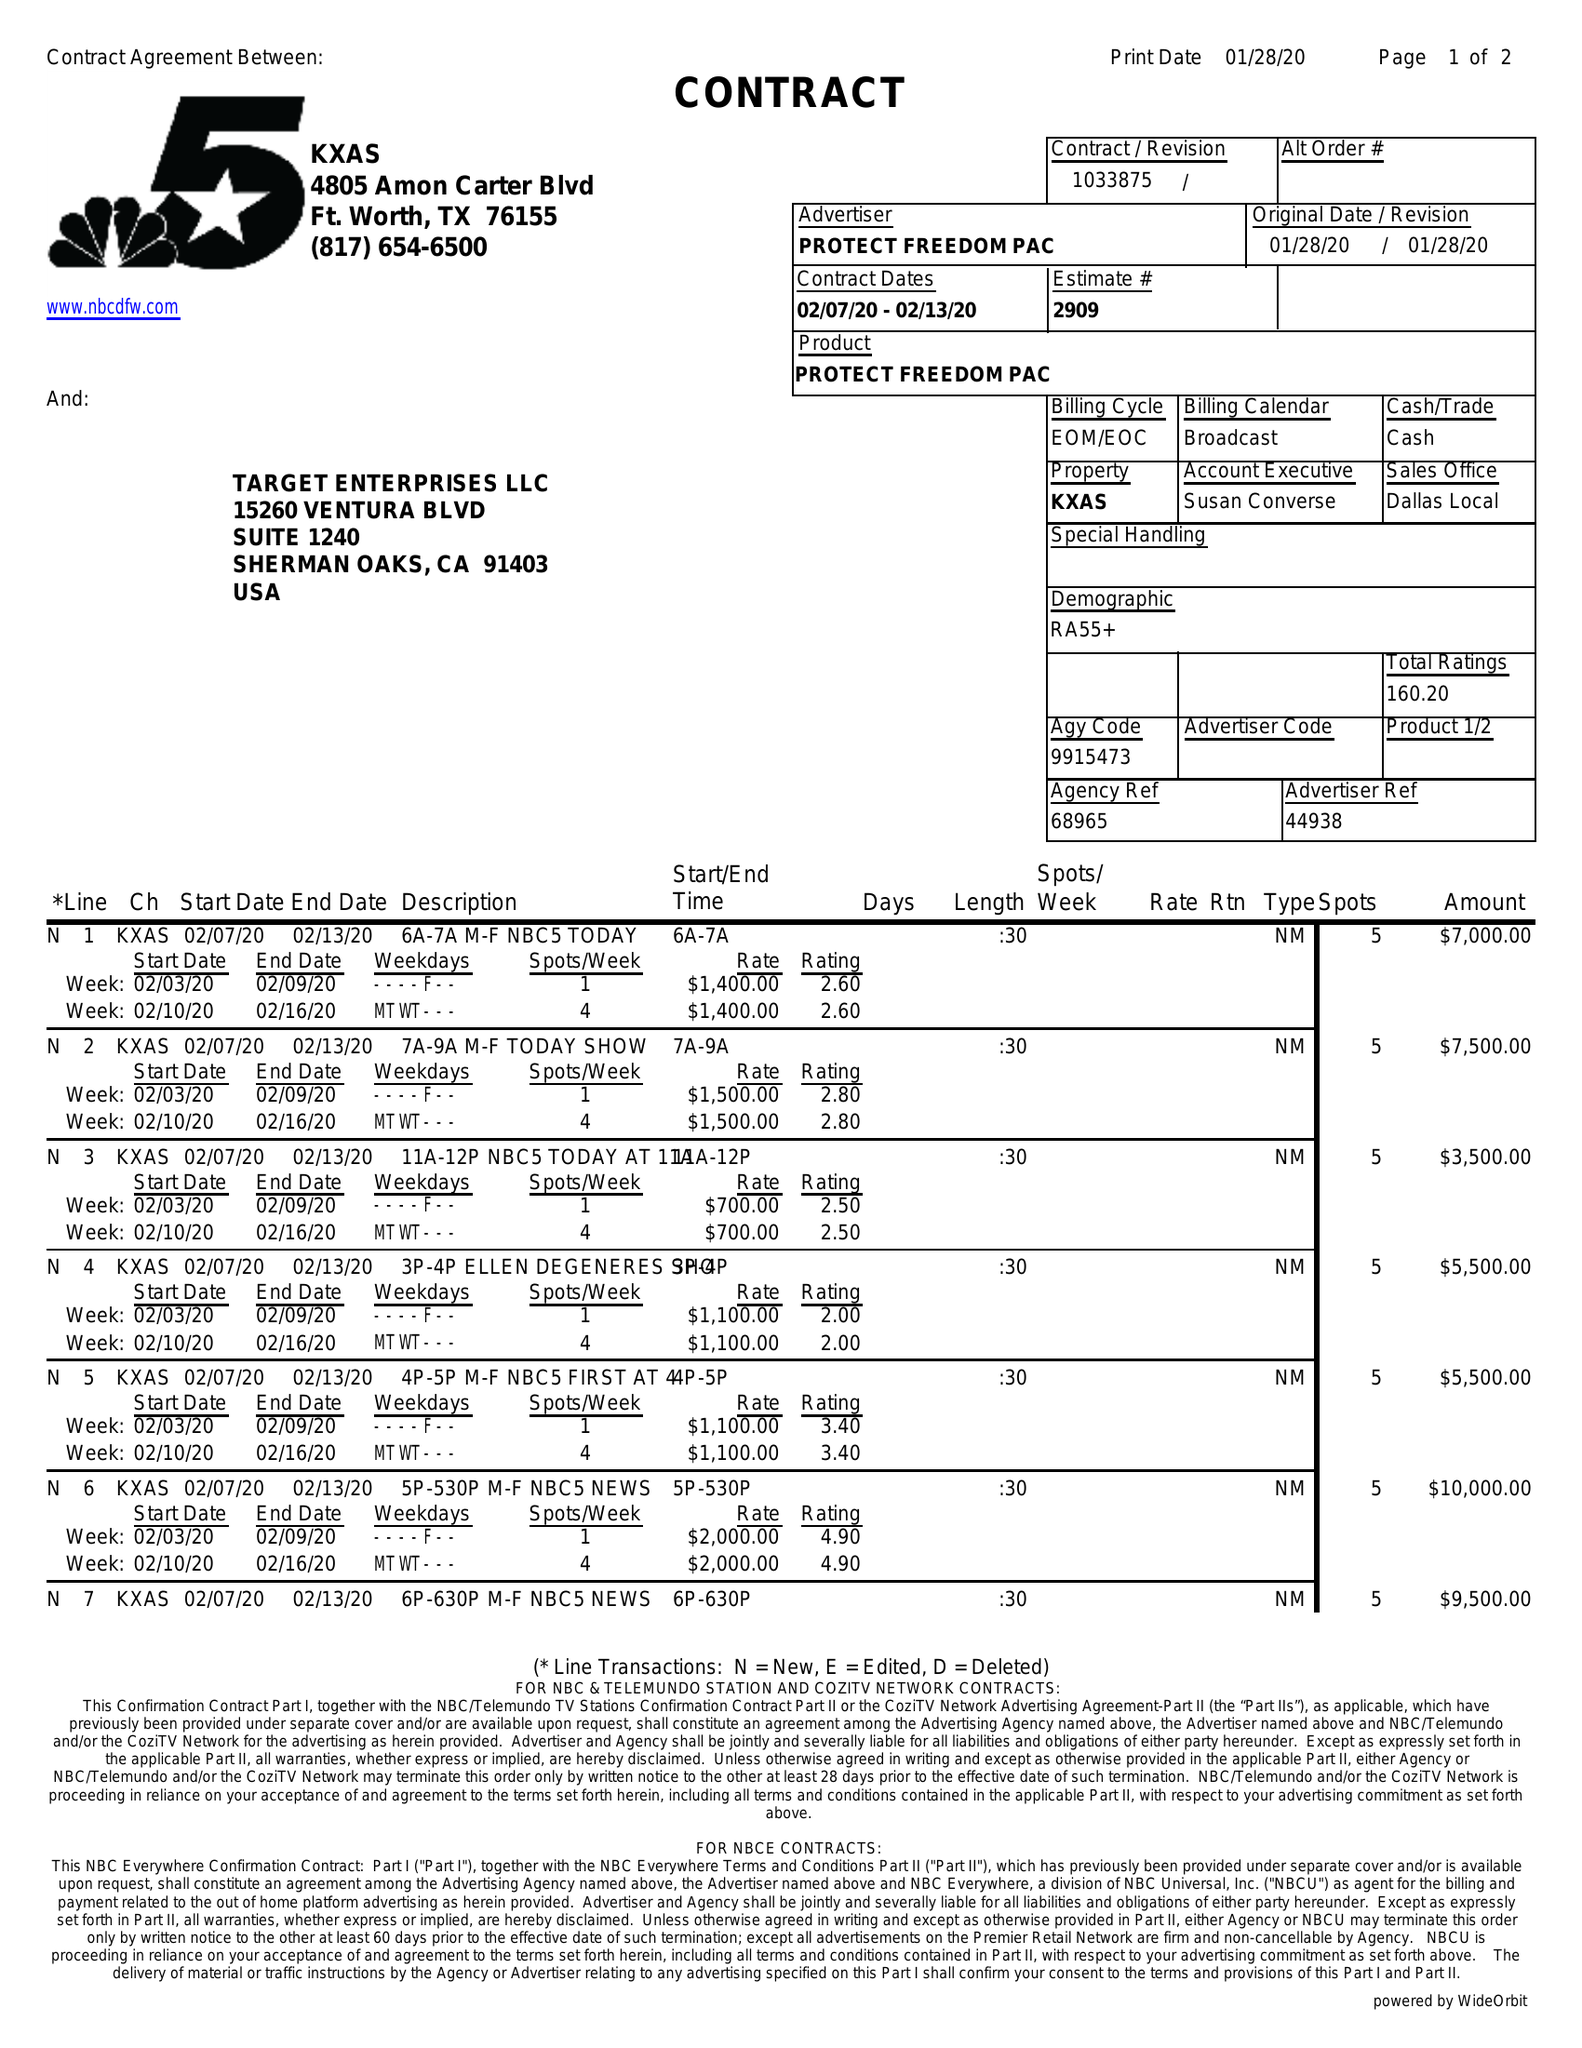What is the value for the contract_num?
Answer the question using a single word or phrase. 1033875 